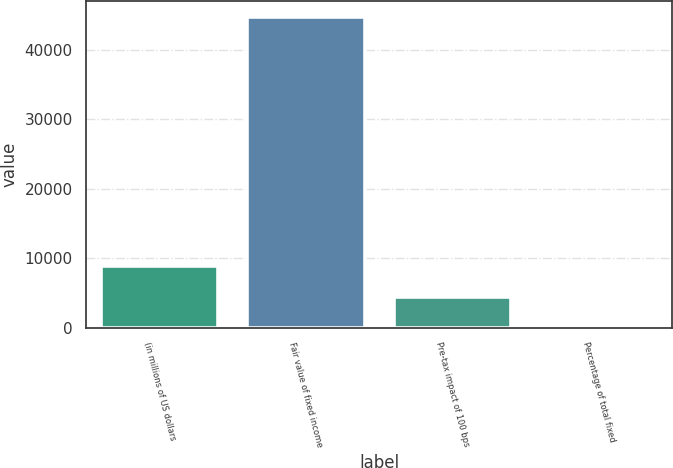<chart> <loc_0><loc_0><loc_500><loc_500><bar_chart><fcel>(in millions of US dollars<fcel>Fair value of fixed income<fcel>Pre-tax impact of 100 bps<fcel>Percentage of total fixed<nl><fcel>8953.48<fcel>44753<fcel>4478.54<fcel>3.6<nl></chart> 